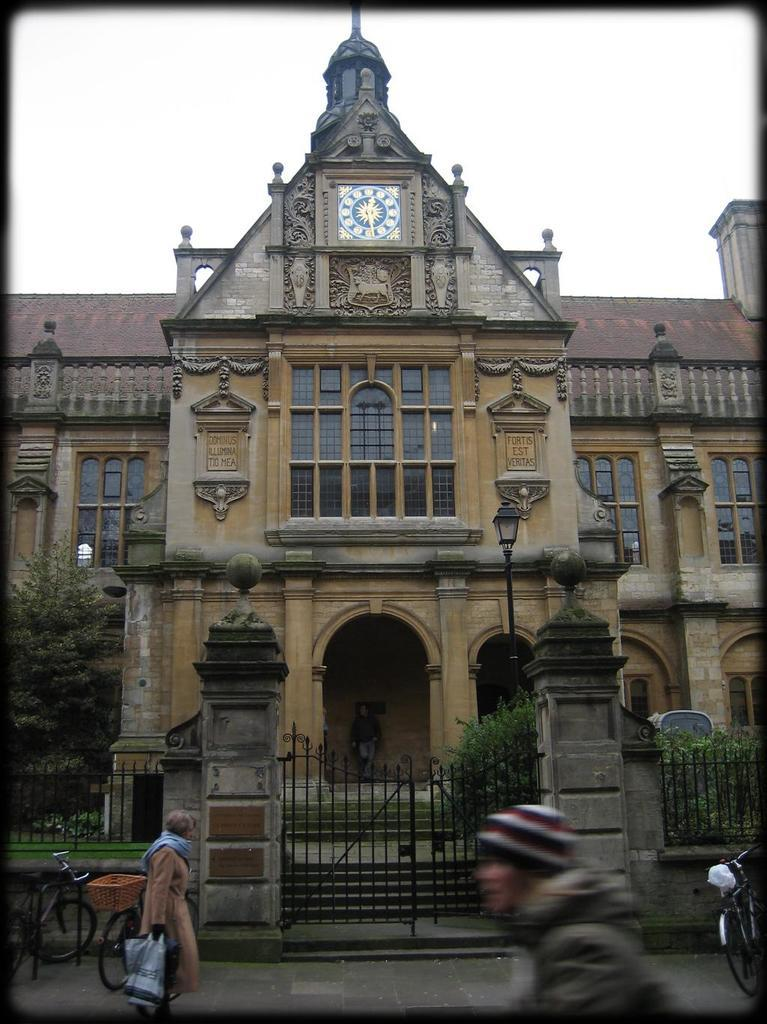How many people are in the image? There are people in the image, but the exact number is not specified. What are the people doing in the image? The image shows people with bicycles, which suggests they might be riding or preparing to ride them. What is the iron gate for in the image? The iron gate is likely a barrier or entrance to a property or area in the image. What type of vegetation is present in the image? Trees are present in the image. What is the pole used for in the image? The pole might be used to support a light or sign in the image. What is the light source in the image? There is a light in the image. What type of structure is in the image? There is a building in the image. What are the windows for in the image? The windows in the image are likely for ventilation and allowing natural light into the building. What is the person carrying in the image? One person is carrying a bag in the image. Where is the basketball court located in the image? There is no basketball court present in the image. What type of screw is being used to hold the building together in the image? There is no mention of screws or any construction details in the image. 